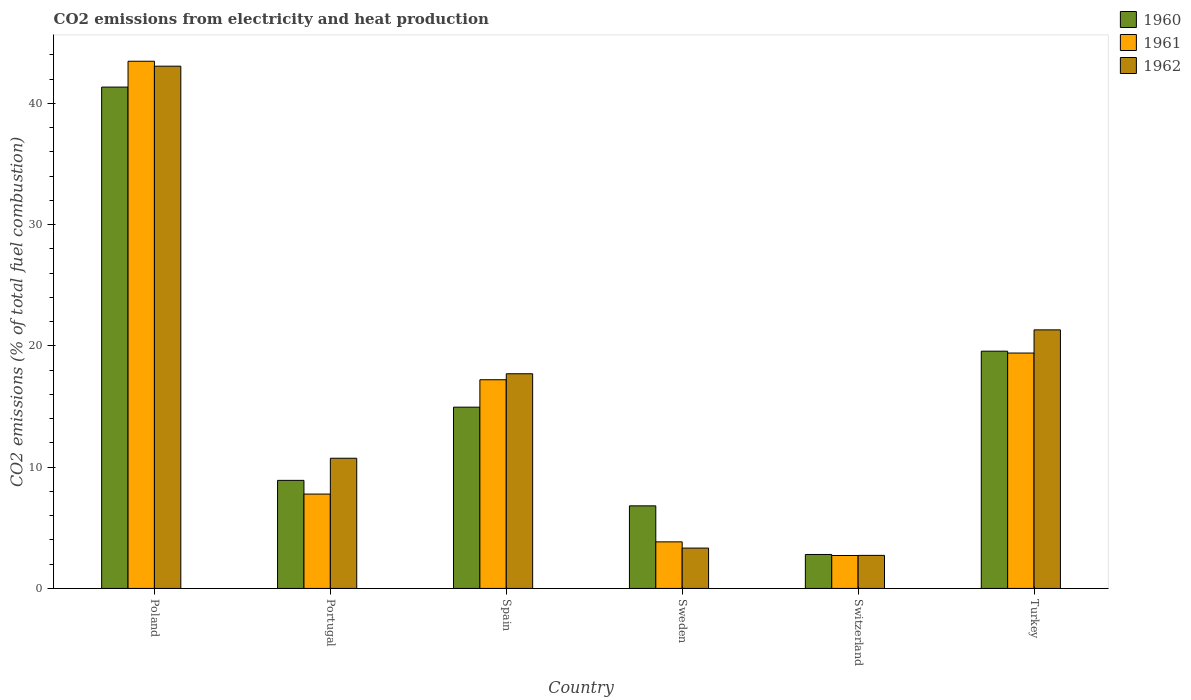Are the number of bars per tick equal to the number of legend labels?
Your answer should be very brief. Yes. How many bars are there on the 2nd tick from the left?
Your response must be concise. 3. How many bars are there on the 2nd tick from the right?
Your response must be concise. 3. In how many cases, is the number of bars for a given country not equal to the number of legend labels?
Your answer should be compact. 0. What is the amount of CO2 emitted in 1961 in Turkey?
Offer a very short reply. 19.41. Across all countries, what is the maximum amount of CO2 emitted in 1962?
Give a very brief answer. 43.06. Across all countries, what is the minimum amount of CO2 emitted in 1961?
Provide a succinct answer. 2.72. In which country was the amount of CO2 emitted in 1961 maximum?
Your response must be concise. Poland. In which country was the amount of CO2 emitted in 1962 minimum?
Your answer should be very brief. Switzerland. What is the total amount of CO2 emitted in 1960 in the graph?
Your answer should be very brief. 94.37. What is the difference between the amount of CO2 emitted in 1960 in Sweden and that in Switzerland?
Offer a terse response. 4.01. What is the difference between the amount of CO2 emitted in 1962 in Spain and the amount of CO2 emitted in 1960 in Sweden?
Make the answer very short. 10.89. What is the average amount of CO2 emitted in 1960 per country?
Offer a very short reply. 15.73. What is the difference between the amount of CO2 emitted of/in 1960 and amount of CO2 emitted of/in 1961 in Switzerland?
Offer a terse response. 0.08. In how many countries, is the amount of CO2 emitted in 1960 greater than 28 %?
Offer a terse response. 1. What is the ratio of the amount of CO2 emitted in 1962 in Sweden to that in Turkey?
Your response must be concise. 0.16. What is the difference between the highest and the second highest amount of CO2 emitted in 1960?
Your answer should be very brief. 21.77. What is the difference between the highest and the lowest amount of CO2 emitted in 1960?
Provide a succinct answer. 38.54. In how many countries, is the amount of CO2 emitted in 1962 greater than the average amount of CO2 emitted in 1962 taken over all countries?
Keep it short and to the point. 3. Is the sum of the amount of CO2 emitted in 1962 in Spain and Switzerland greater than the maximum amount of CO2 emitted in 1961 across all countries?
Provide a short and direct response. No. What does the 3rd bar from the right in Switzerland represents?
Keep it short and to the point. 1960. Is it the case that in every country, the sum of the amount of CO2 emitted in 1961 and amount of CO2 emitted in 1962 is greater than the amount of CO2 emitted in 1960?
Keep it short and to the point. Yes. How many bars are there?
Give a very brief answer. 18. How many countries are there in the graph?
Your answer should be very brief. 6. Are the values on the major ticks of Y-axis written in scientific E-notation?
Keep it short and to the point. No. How many legend labels are there?
Make the answer very short. 3. What is the title of the graph?
Your answer should be very brief. CO2 emissions from electricity and heat production. Does "2002" appear as one of the legend labels in the graph?
Your answer should be very brief. No. What is the label or title of the Y-axis?
Your answer should be compact. CO2 emissions (% of total fuel combustion). What is the CO2 emissions (% of total fuel combustion) of 1960 in Poland?
Keep it short and to the point. 41.34. What is the CO2 emissions (% of total fuel combustion) in 1961 in Poland?
Give a very brief answer. 43.47. What is the CO2 emissions (% of total fuel combustion) in 1962 in Poland?
Offer a very short reply. 43.06. What is the CO2 emissions (% of total fuel combustion) of 1960 in Portugal?
Give a very brief answer. 8.91. What is the CO2 emissions (% of total fuel combustion) in 1961 in Portugal?
Your answer should be very brief. 7.78. What is the CO2 emissions (% of total fuel combustion) of 1962 in Portugal?
Your answer should be very brief. 10.73. What is the CO2 emissions (% of total fuel combustion) in 1960 in Spain?
Your answer should be compact. 14.95. What is the CO2 emissions (% of total fuel combustion) of 1961 in Spain?
Provide a succinct answer. 17.21. What is the CO2 emissions (% of total fuel combustion) of 1962 in Spain?
Ensure brevity in your answer.  17.7. What is the CO2 emissions (% of total fuel combustion) of 1960 in Sweden?
Offer a very short reply. 6.81. What is the CO2 emissions (% of total fuel combustion) of 1961 in Sweden?
Provide a short and direct response. 3.84. What is the CO2 emissions (% of total fuel combustion) in 1962 in Sweden?
Keep it short and to the point. 3.33. What is the CO2 emissions (% of total fuel combustion) in 1960 in Switzerland?
Make the answer very short. 2.8. What is the CO2 emissions (% of total fuel combustion) of 1961 in Switzerland?
Offer a terse response. 2.72. What is the CO2 emissions (% of total fuel combustion) of 1962 in Switzerland?
Your answer should be compact. 2.72. What is the CO2 emissions (% of total fuel combustion) of 1960 in Turkey?
Provide a short and direct response. 19.56. What is the CO2 emissions (% of total fuel combustion) of 1961 in Turkey?
Your answer should be compact. 19.41. What is the CO2 emissions (% of total fuel combustion) in 1962 in Turkey?
Offer a terse response. 21.32. Across all countries, what is the maximum CO2 emissions (% of total fuel combustion) of 1960?
Your answer should be very brief. 41.34. Across all countries, what is the maximum CO2 emissions (% of total fuel combustion) of 1961?
Keep it short and to the point. 43.47. Across all countries, what is the maximum CO2 emissions (% of total fuel combustion) in 1962?
Your answer should be very brief. 43.06. Across all countries, what is the minimum CO2 emissions (% of total fuel combustion) of 1960?
Provide a short and direct response. 2.8. Across all countries, what is the minimum CO2 emissions (% of total fuel combustion) in 1961?
Offer a very short reply. 2.72. Across all countries, what is the minimum CO2 emissions (% of total fuel combustion) in 1962?
Your answer should be very brief. 2.72. What is the total CO2 emissions (% of total fuel combustion) of 1960 in the graph?
Ensure brevity in your answer.  94.37. What is the total CO2 emissions (% of total fuel combustion) of 1961 in the graph?
Provide a succinct answer. 94.42. What is the total CO2 emissions (% of total fuel combustion) of 1962 in the graph?
Provide a short and direct response. 98.87. What is the difference between the CO2 emissions (% of total fuel combustion) in 1960 in Poland and that in Portugal?
Ensure brevity in your answer.  32.43. What is the difference between the CO2 emissions (% of total fuel combustion) in 1961 in Poland and that in Portugal?
Offer a very short reply. 35.69. What is the difference between the CO2 emissions (% of total fuel combustion) in 1962 in Poland and that in Portugal?
Keep it short and to the point. 32.33. What is the difference between the CO2 emissions (% of total fuel combustion) in 1960 in Poland and that in Spain?
Make the answer very short. 26.39. What is the difference between the CO2 emissions (% of total fuel combustion) in 1961 in Poland and that in Spain?
Give a very brief answer. 26.26. What is the difference between the CO2 emissions (% of total fuel combustion) of 1962 in Poland and that in Spain?
Offer a very short reply. 25.36. What is the difference between the CO2 emissions (% of total fuel combustion) in 1960 in Poland and that in Sweden?
Provide a short and direct response. 34.53. What is the difference between the CO2 emissions (% of total fuel combustion) in 1961 in Poland and that in Sweden?
Keep it short and to the point. 39.63. What is the difference between the CO2 emissions (% of total fuel combustion) in 1962 in Poland and that in Sweden?
Give a very brief answer. 39.73. What is the difference between the CO2 emissions (% of total fuel combustion) in 1960 in Poland and that in Switzerland?
Provide a succinct answer. 38.54. What is the difference between the CO2 emissions (% of total fuel combustion) of 1961 in Poland and that in Switzerland?
Your answer should be compact. 40.75. What is the difference between the CO2 emissions (% of total fuel combustion) in 1962 in Poland and that in Switzerland?
Keep it short and to the point. 40.34. What is the difference between the CO2 emissions (% of total fuel combustion) in 1960 in Poland and that in Turkey?
Make the answer very short. 21.77. What is the difference between the CO2 emissions (% of total fuel combustion) of 1961 in Poland and that in Turkey?
Your answer should be compact. 24.06. What is the difference between the CO2 emissions (% of total fuel combustion) of 1962 in Poland and that in Turkey?
Your response must be concise. 21.74. What is the difference between the CO2 emissions (% of total fuel combustion) of 1960 in Portugal and that in Spain?
Ensure brevity in your answer.  -6.04. What is the difference between the CO2 emissions (% of total fuel combustion) of 1961 in Portugal and that in Spain?
Your answer should be compact. -9.43. What is the difference between the CO2 emissions (% of total fuel combustion) in 1962 in Portugal and that in Spain?
Offer a very short reply. -6.97. What is the difference between the CO2 emissions (% of total fuel combustion) of 1960 in Portugal and that in Sweden?
Your answer should be compact. 2.1. What is the difference between the CO2 emissions (% of total fuel combustion) of 1961 in Portugal and that in Sweden?
Make the answer very short. 3.94. What is the difference between the CO2 emissions (% of total fuel combustion) in 1962 in Portugal and that in Sweden?
Your answer should be compact. 7.41. What is the difference between the CO2 emissions (% of total fuel combustion) in 1960 in Portugal and that in Switzerland?
Ensure brevity in your answer.  6.11. What is the difference between the CO2 emissions (% of total fuel combustion) in 1961 in Portugal and that in Switzerland?
Provide a succinct answer. 5.07. What is the difference between the CO2 emissions (% of total fuel combustion) of 1962 in Portugal and that in Switzerland?
Provide a short and direct response. 8.01. What is the difference between the CO2 emissions (% of total fuel combustion) in 1960 in Portugal and that in Turkey?
Your answer should be compact. -10.65. What is the difference between the CO2 emissions (% of total fuel combustion) of 1961 in Portugal and that in Turkey?
Provide a short and direct response. -11.63. What is the difference between the CO2 emissions (% of total fuel combustion) in 1962 in Portugal and that in Turkey?
Keep it short and to the point. -10.59. What is the difference between the CO2 emissions (% of total fuel combustion) in 1960 in Spain and that in Sweden?
Give a very brief answer. 8.14. What is the difference between the CO2 emissions (% of total fuel combustion) of 1961 in Spain and that in Sweden?
Make the answer very short. 13.37. What is the difference between the CO2 emissions (% of total fuel combustion) in 1962 in Spain and that in Sweden?
Offer a very short reply. 14.37. What is the difference between the CO2 emissions (% of total fuel combustion) in 1960 in Spain and that in Switzerland?
Make the answer very short. 12.15. What is the difference between the CO2 emissions (% of total fuel combustion) in 1961 in Spain and that in Switzerland?
Make the answer very short. 14.49. What is the difference between the CO2 emissions (% of total fuel combustion) of 1962 in Spain and that in Switzerland?
Make the answer very short. 14.98. What is the difference between the CO2 emissions (% of total fuel combustion) of 1960 in Spain and that in Turkey?
Provide a succinct answer. -4.62. What is the difference between the CO2 emissions (% of total fuel combustion) in 1961 in Spain and that in Turkey?
Keep it short and to the point. -2.2. What is the difference between the CO2 emissions (% of total fuel combustion) of 1962 in Spain and that in Turkey?
Make the answer very short. -3.62. What is the difference between the CO2 emissions (% of total fuel combustion) of 1960 in Sweden and that in Switzerland?
Your answer should be very brief. 4.01. What is the difference between the CO2 emissions (% of total fuel combustion) of 1961 in Sweden and that in Switzerland?
Make the answer very short. 1.12. What is the difference between the CO2 emissions (% of total fuel combustion) in 1962 in Sweden and that in Switzerland?
Keep it short and to the point. 0.6. What is the difference between the CO2 emissions (% of total fuel combustion) in 1960 in Sweden and that in Turkey?
Your answer should be very brief. -12.75. What is the difference between the CO2 emissions (% of total fuel combustion) of 1961 in Sweden and that in Turkey?
Offer a terse response. -15.57. What is the difference between the CO2 emissions (% of total fuel combustion) in 1962 in Sweden and that in Turkey?
Your answer should be very brief. -17.99. What is the difference between the CO2 emissions (% of total fuel combustion) in 1960 in Switzerland and that in Turkey?
Your answer should be compact. -16.76. What is the difference between the CO2 emissions (% of total fuel combustion) in 1961 in Switzerland and that in Turkey?
Your response must be concise. -16.69. What is the difference between the CO2 emissions (% of total fuel combustion) of 1962 in Switzerland and that in Turkey?
Provide a succinct answer. -18.59. What is the difference between the CO2 emissions (% of total fuel combustion) in 1960 in Poland and the CO2 emissions (% of total fuel combustion) in 1961 in Portugal?
Make the answer very short. 33.56. What is the difference between the CO2 emissions (% of total fuel combustion) of 1960 in Poland and the CO2 emissions (% of total fuel combustion) of 1962 in Portugal?
Provide a short and direct response. 30.6. What is the difference between the CO2 emissions (% of total fuel combustion) of 1961 in Poland and the CO2 emissions (% of total fuel combustion) of 1962 in Portugal?
Offer a terse response. 32.73. What is the difference between the CO2 emissions (% of total fuel combustion) in 1960 in Poland and the CO2 emissions (% of total fuel combustion) in 1961 in Spain?
Provide a short and direct response. 24.13. What is the difference between the CO2 emissions (% of total fuel combustion) in 1960 in Poland and the CO2 emissions (% of total fuel combustion) in 1962 in Spain?
Your answer should be very brief. 23.64. What is the difference between the CO2 emissions (% of total fuel combustion) of 1961 in Poland and the CO2 emissions (% of total fuel combustion) of 1962 in Spain?
Your response must be concise. 25.77. What is the difference between the CO2 emissions (% of total fuel combustion) in 1960 in Poland and the CO2 emissions (% of total fuel combustion) in 1961 in Sweden?
Your answer should be very brief. 37.5. What is the difference between the CO2 emissions (% of total fuel combustion) in 1960 in Poland and the CO2 emissions (% of total fuel combustion) in 1962 in Sweden?
Make the answer very short. 38.01. What is the difference between the CO2 emissions (% of total fuel combustion) of 1961 in Poland and the CO2 emissions (% of total fuel combustion) of 1962 in Sweden?
Provide a succinct answer. 40.14. What is the difference between the CO2 emissions (% of total fuel combustion) in 1960 in Poland and the CO2 emissions (% of total fuel combustion) in 1961 in Switzerland?
Provide a succinct answer. 38.62. What is the difference between the CO2 emissions (% of total fuel combustion) of 1960 in Poland and the CO2 emissions (% of total fuel combustion) of 1962 in Switzerland?
Provide a succinct answer. 38.61. What is the difference between the CO2 emissions (% of total fuel combustion) of 1961 in Poland and the CO2 emissions (% of total fuel combustion) of 1962 in Switzerland?
Your answer should be compact. 40.74. What is the difference between the CO2 emissions (% of total fuel combustion) in 1960 in Poland and the CO2 emissions (% of total fuel combustion) in 1961 in Turkey?
Provide a short and direct response. 21.93. What is the difference between the CO2 emissions (% of total fuel combustion) of 1960 in Poland and the CO2 emissions (% of total fuel combustion) of 1962 in Turkey?
Provide a short and direct response. 20.02. What is the difference between the CO2 emissions (% of total fuel combustion) in 1961 in Poland and the CO2 emissions (% of total fuel combustion) in 1962 in Turkey?
Your response must be concise. 22.15. What is the difference between the CO2 emissions (% of total fuel combustion) in 1960 in Portugal and the CO2 emissions (% of total fuel combustion) in 1961 in Spain?
Provide a succinct answer. -8.3. What is the difference between the CO2 emissions (% of total fuel combustion) of 1960 in Portugal and the CO2 emissions (% of total fuel combustion) of 1962 in Spain?
Your response must be concise. -8.79. What is the difference between the CO2 emissions (% of total fuel combustion) of 1961 in Portugal and the CO2 emissions (% of total fuel combustion) of 1962 in Spain?
Offer a very short reply. -9.92. What is the difference between the CO2 emissions (% of total fuel combustion) in 1960 in Portugal and the CO2 emissions (% of total fuel combustion) in 1961 in Sweden?
Your answer should be very brief. 5.07. What is the difference between the CO2 emissions (% of total fuel combustion) in 1960 in Portugal and the CO2 emissions (% of total fuel combustion) in 1962 in Sweden?
Keep it short and to the point. 5.58. What is the difference between the CO2 emissions (% of total fuel combustion) of 1961 in Portugal and the CO2 emissions (% of total fuel combustion) of 1962 in Sweden?
Offer a terse response. 4.45. What is the difference between the CO2 emissions (% of total fuel combustion) in 1960 in Portugal and the CO2 emissions (% of total fuel combustion) in 1961 in Switzerland?
Keep it short and to the point. 6.2. What is the difference between the CO2 emissions (% of total fuel combustion) in 1960 in Portugal and the CO2 emissions (% of total fuel combustion) in 1962 in Switzerland?
Your response must be concise. 6.19. What is the difference between the CO2 emissions (% of total fuel combustion) in 1961 in Portugal and the CO2 emissions (% of total fuel combustion) in 1962 in Switzerland?
Offer a terse response. 5.06. What is the difference between the CO2 emissions (% of total fuel combustion) in 1960 in Portugal and the CO2 emissions (% of total fuel combustion) in 1961 in Turkey?
Make the answer very short. -10.5. What is the difference between the CO2 emissions (% of total fuel combustion) of 1960 in Portugal and the CO2 emissions (% of total fuel combustion) of 1962 in Turkey?
Your response must be concise. -12.41. What is the difference between the CO2 emissions (% of total fuel combustion) of 1961 in Portugal and the CO2 emissions (% of total fuel combustion) of 1962 in Turkey?
Your answer should be very brief. -13.54. What is the difference between the CO2 emissions (% of total fuel combustion) of 1960 in Spain and the CO2 emissions (% of total fuel combustion) of 1961 in Sweden?
Your answer should be compact. 11.11. What is the difference between the CO2 emissions (% of total fuel combustion) of 1960 in Spain and the CO2 emissions (% of total fuel combustion) of 1962 in Sweden?
Your response must be concise. 11.62. What is the difference between the CO2 emissions (% of total fuel combustion) of 1961 in Spain and the CO2 emissions (% of total fuel combustion) of 1962 in Sweden?
Your answer should be compact. 13.88. What is the difference between the CO2 emissions (% of total fuel combustion) of 1960 in Spain and the CO2 emissions (% of total fuel combustion) of 1961 in Switzerland?
Provide a succinct answer. 12.23. What is the difference between the CO2 emissions (% of total fuel combustion) in 1960 in Spain and the CO2 emissions (% of total fuel combustion) in 1962 in Switzerland?
Offer a terse response. 12.22. What is the difference between the CO2 emissions (% of total fuel combustion) in 1961 in Spain and the CO2 emissions (% of total fuel combustion) in 1962 in Switzerland?
Ensure brevity in your answer.  14.48. What is the difference between the CO2 emissions (% of total fuel combustion) in 1960 in Spain and the CO2 emissions (% of total fuel combustion) in 1961 in Turkey?
Make the answer very short. -4.46. What is the difference between the CO2 emissions (% of total fuel combustion) in 1960 in Spain and the CO2 emissions (% of total fuel combustion) in 1962 in Turkey?
Your answer should be compact. -6.37. What is the difference between the CO2 emissions (% of total fuel combustion) in 1961 in Spain and the CO2 emissions (% of total fuel combustion) in 1962 in Turkey?
Provide a succinct answer. -4.11. What is the difference between the CO2 emissions (% of total fuel combustion) of 1960 in Sweden and the CO2 emissions (% of total fuel combustion) of 1961 in Switzerland?
Your answer should be very brief. 4.09. What is the difference between the CO2 emissions (% of total fuel combustion) of 1960 in Sweden and the CO2 emissions (% of total fuel combustion) of 1962 in Switzerland?
Offer a terse response. 4.08. What is the difference between the CO2 emissions (% of total fuel combustion) in 1961 in Sweden and the CO2 emissions (% of total fuel combustion) in 1962 in Switzerland?
Provide a short and direct response. 1.12. What is the difference between the CO2 emissions (% of total fuel combustion) in 1960 in Sweden and the CO2 emissions (% of total fuel combustion) in 1961 in Turkey?
Offer a terse response. -12.6. What is the difference between the CO2 emissions (% of total fuel combustion) of 1960 in Sweden and the CO2 emissions (% of total fuel combustion) of 1962 in Turkey?
Offer a very short reply. -14.51. What is the difference between the CO2 emissions (% of total fuel combustion) of 1961 in Sweden and the CO2 emissions (% of total fuel combustion) of 1962 in Turkey?
Give a very brief answer. -17.48. What is the difference between the CO2 emissions (% of total fuel combustion) of 1960 in Switzerland and the CO2 emissions (% of total fuel combustion) of 1961 in Turkey?
Your answer should be compact. -16.61. What is the difference between the CO2 emissions (% of total fuel combustion) of 1960 in Switzerland and the CO2 emissions (% of total fuel combustion) of 1962 in Turkey?
Ensure brevity in your answer.  -18.52. What is the difference between the CO2 emissions (% of total fuel combustion) of 1961 in Switzerland and the CO2 emissions (% of total fuel combustion) of 1962 in Turkey?
Your response must be concise. -18.6. What is the average CO2 emissions (% of total fuel combustion) of 1960 per country?
Provide a short and direct response. 15.73. What is the average CO2 emissions (% of total fuel combustion) of 1961 per country?
Keep it short and to the point. 15.74. What is the average CO2 emissions (% of total fuel combustion) of 1962 per country?
Your answer should be very brief. 16.48. What is the difference between the CO2 emissions (% of total fuel combustion) in 1960 and CO2 emissions (% of total fuel combustion) in 1961 in Poland?
Your response must be concise. -2.13. What is the difference between the CO2 emissions (% of total fuel combustion) in 1960 and CO2 emissions (% of total fuel combustion) in 1962 in Poland?
Give a very brief answer. -1.72. What is the difference between the CO2 emissions (% of total fuel combustion) in 1961 and CO2 emissions (% of total fuel combustion) in 1962 in Poland?
Offer a terse response. 0.41. What is the difference between the CO2 emissions (% of total fuel combustion) of 1960 and CO2 emissions (% of total fuel combustion) of 1961 in Portugal?
Your response must be concise. 1.13. What is the difference between the CO2 emissions (% of total fuel combustion) of 1960 and CO2 emissions (% of total fuel combustion) of 1962 in Portugal?
Keep it short and to the point. -1.82. What is the difference between the CO2 emissions (% of total fuel combustion) of 1961 and CO2 emissions (% of total fuel combustion) of 1962 in Portugal?
Your answer should be compact. -2.95. What is the difference between the CO2 emissions (% of total fuel combustion) of 1960 and CO2 emissions (% of total fuel combustion) of 1961 in Spain?
Your answer should be very brief. -2.26. What is the difference between the CO2 emissions (% of total fuel combustion) in 1960 and CO2 emissions (% of total fuel combustion) in 1962 in Spain?
Ensure brevity in your answer.  -2.75. What is the difference between the CO2 emissions (% of total fuel combustion) in 1961 and CO2 emissions (% of total fuel combustion) in 1962 in Spain?
Your answer should be very brief. -0.49. What is the difference between the CO2 emissions (% of total fuel combustion) of 1960 and CO2 emissions (% of total fuel combustion) of 1961 in Sweden?
Provide a short and direct response. 2.97. What is the difference between the CO2 emissions (% of total fuel combustion) in 1960 and CO2 emissions (% of total fuel combustion) in 1962 in Sweden?
Offer a terse response. 3.48. What is the difference between the CO2 emissions (% of total fuel combustion) of 1961 and CO2 emissions (% of total fuel combustion) of 1962 in Sweden?
Give a very brief answer. 0.51. What is the difference between the CO2 emissions (% of total fuel combustion) of 1960 and CO2 emissions (% of total fuel combustion) of 1961 in Switzerland?
Your answer should be compact. 0.08. What is the difference between the CO2 emissions (% of total fuel combustion) of 1960 and CO2 emissions (% of total fuel combustion) of 1962 in Switzerland?
Provide a short and direct response. 0.07. What is the difference between the CO2 emissions (% of total fuel combustion) of 1961 and CO2 emissions (% of total fuel combustion) of 1962 in Switzerland?
Ensure brevity in your answer.  -0.01. What is the difference between the CO2 emissions (% of total fuel combustion) of 1960 and CO2 emissions (% of total fuel combustion) of 1961 in Turkey?
Ensure brevity in your answer.  0.15. What is the difference between the CO2 emissions (% of total fuel combustion) in 1960 and CO2 emissions (% of total fuel combustion) in 1962 in Turkey?
Keep it short and to the point. -1.76. What is the difference between the CO2 emissions (% of total fuel combustion) of 1961 and CO2 emissions (% of total fuel combustion) of 1962 in Turkey?
Your response must be concise. -1.91. What is the ratio of the CO2 emissions (% of total fuel combustion) in 1960 in Poland to that in Portugal?
Provide a succinct answer. 4.64. What is the ratio of the CO2 emissions (% of total fuel combustion) in 1961 in Poland to that in Portugal?
Keep it short and to the point. 5.59. What is the ratio of the CO2 emissions (% of total fuel combustion) in 1962 in Poland to that in Portugal?
Provide a succinct answer. 4.01. What is the ratio of the CO2 emissions (% of total fuel combustion) of 1960 in Poland to that in Spain?
Your answer should be very brief. 2.77. What is the ratio of the CO2 emissions (% of total fuel combustion) in 1961 in Poland to that in Spain?
Make the answer very short. 2.53. What is the ratio of the CO2 emissions (% of total fuel combustion) of 1962 in Poland to that in Spain?
Provide a short and direct response. 2.43. What is the ratio of the CO2 emissions (% of total fuel combustion) of 1960 in Poland to that in Sweden?
Give a very brief answer. 6.07. What is the ratio of the CO2 emissions (% of total fuel combustion) of 1961 in Poland to that in Sweden?
Your response must be concise. 11.32. What is the ratio of the CO2 emissions (% of total fuel combustion) of 1962 in Poland to that in Sweden?
Provide a short and direct response. 12.94. What is the ratio of the CO2 emissions (% of total fuel combustion) of 1960 in Poland to that in Switzerland?
Provide a short and direct response. 14.77. What is the ratio of the CO2 emissions (% of total fuel combustion) of 1961 in Poland to that in Switzerland?
Offer a very short reply. 16.01. What is the ratio of the CO2 emissions (% of total fuel combustion) in 1962 in Poland to that in Switzerland?
Ensure brevity in your answer.  15.8. What is the ratio of the CO2 emissions (% of total fuel combustion) of 1960 in Poland to that in Turkey?
Ensure brevity in your answer.  2.11. What is the ratio of the CO2 emissions (% of total fuel combustion) of 1961 in Poland to that in Turkey?
Offer a very short reply. 2.24. What is the ratio of the CO2 emissions (% of total fuel combustion) of 1962 in Poland to that in Turkey?
Give a very brief answer. 2.02. What is the ratio of the CO2 emissions (% of total fuel combustion) of 1960 in Portugal to that in Spain?
Offer a terse response. 0.6. What is the ratio of the CO2 emissions (% of total fuel combustion) of 1961 in Portugal to that in Spain?
Provide a short and direct response. 0.45. What is the ratio of the CO2 emissions (% of total fuel combustion) in 1962 in Portugal to that in Spain?
Keep it short and to the point. 0.61. What is the ratio of the CO2 emissions (% of total fuel combustion) of 1960 in Portugal to that in Sweden?
Your answer should be very brief. 1.31. What is the ratio of the CO2 emissions (% of total fuel combustion) of 1961 in Portugal to that in Sweden?
Your response must be concise. 2.03. What is the ratio of the CO2 emissions (% of total fuel combustion) of 1962 in Portugal to that in Sweden?
Keep it short and to the point. 3.23. What is the ratio of the CO2 emissions (% of total fuel combustion) in 1960 in Portugal to that in Switzerland?
Provide a succinct answer. 3.18. What is the ratio of the CO2 emissions (% of total fuel combustion) in 1961 in Portugal to that in Switzerland?
Ensure brevity in your answer.  2.87. What is the ratio of the CO2 emissions (% of total fuel combustion) of 1962 in Portugal to that in Switzerland?
Keep it short and to the point. 3.94. What is the ratio of the CO2 emissions (% of total fuel combustion) of 1960 in Portugal to that in Turkey?
Give a very brief answer. 0.46. What is the ratio of the CO2 emissions (% of total fuel combustion) of 1961 in Portugal to that in Turkey?
Make the answer very short. 0.4. What is the ratio of the CO2 emissions (% of total fuel combustion) in 1962 in Portugal to that in Turkey?
Your answer should be compact. 0.5. What is the ratio of the CO2 emissions (% of total fuel combustion) of 1960 in Spain to that in Sweden?
Offer a terse response. 2.2. What is the ratio of the CO2 emissions (% of total fuel combustion) in 1961 in Spain to that in Sweden?
Provide a succinct answer. 4.48. What is the ratio of the CO2 emissions (% of total fuel combustion) of 1962 in Spain to that in Sweden?
Your response must be concise. 5.32. What is the ratio of the CO2 emissions (% of total fuel combustion) of 1960 in Spain to that in Switzerland?
Your response must be concise. 5.34. What is the ratio of the CO2 emissions (% of total fuel combustion) of 1961 in Spain to that in Switzerland?
Offer a very short reply. 6.34. What is the ratio of the CO2 emissions (% of total fuel combustion) of 1962 in Spain to that in Switzerland?
Your response must be concise. 6.5. What is the ratio of the CO2 emissions (% of total fuel combustion) in 1960 in Spain to that in Turkey?
Provide a succinct answer. 0.76. What is the ratio of the CO2 emissions (% of total fuel combustion) of 1961 in Spain to that in Turkey?
Provide a short and direct response. 0.89. What is the ratio of the CO2 emissions (% of total fuel combustion) in 1962 in Spain to that in Turkey?
Provide a succinct answer. 0.83. What is the ratio of the CO2 emissions (% of total fuel combustion) of 1960 in Sweden to that in Switzerland?
Offer a very short reply. 2.43. What is the ratio of the CO2 emissions (% of total fuel combustion) of 1961 in Sweden to that in Switzerland?
Ensure brevity in your answer.  1.41. What is the ratio of the CO2 emissions (% of total fuel combustion) in 1962 in Sweden to that in Switzerland?
Provide a succinct answer. 1.22. What is the ratio of the CO2 emissions (% of total fuel combustion) of 1960 in Sweden to that in Turkey?
Offer a very short reply. 0.35. What is the ratio of the CO2 emissions (% of total fuel combustion) in 1961 in Sweden to that in Turkey?
Ensure brevity in your answer.  0.2. What is the ratio of the CO2 emissions (% of total fuel combustion) of 1962 in Sweden to that in Turkey?
Provide a succinct answer. 0.16. What is the ratio of the CO2 emissions (% of total fuel combustion) of 1960 in Switzerland to that in Turkey?
Ensure brevity in your answer.  0.14. What is the ratio of the CO2 emissions (% of total fuel combustion) in 1961 in Switzerland to that in Turkey?
Your response must be concise. 0.14. What is the ratio of the CO2 emissions (% of total fuel combustion) of 1962 in Switzerland to that in Turkey?
Your answer should be very brief. 0.13. What is the difference between the highest and the second highest CO2 emissions (% of total fuel combustion) in 1960?
Your answer should be compact. 21.77. What is the difference between the highest and the second highest CO2 emissions (% of total fuel combustion) in 1961?
Provide a short and direct response. 24.06. What is the difference between the highest and the second highest CO2 emissions (% of total fuel combustion) in 1962?
Keep it short and to the point. 21.74. What is the difference between the highest and the lowest CO2 emissions (% of total fuel combustion) in 1960?
Your answer should be compact. 38.54. What is the difference between the highest and the lowest CO2 emissions (% of total fuel combustion) in 1961?
Give a very brief answer. 40.75. What is the difference between the highest and the lowest CO2 emissions (% of total fuel combustion) of 1962?
Offer a very short reply. 40.34. 